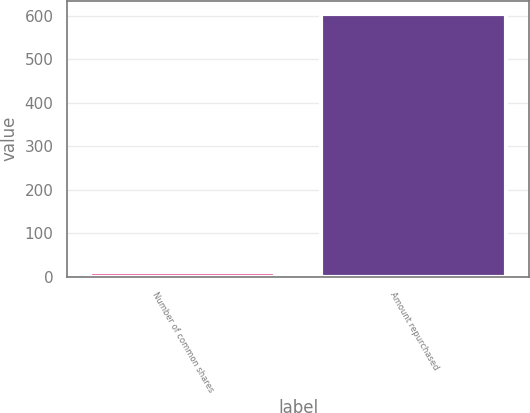<chart> <loc_0><loc_0><loc_500><loc_500><bar_chart><fcel>Number of common shares<fcel>Amount repurchased<nl><fcel>11<fcel>604<nl></chart> 